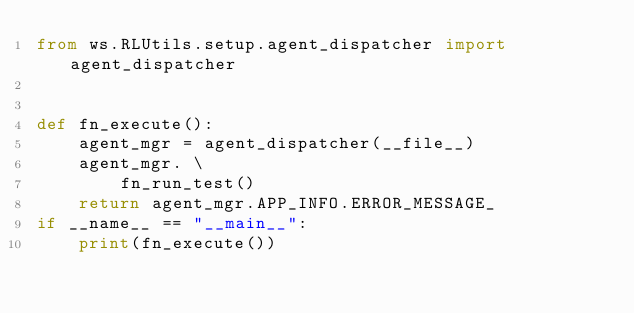Convert code to text. <code><loc_0><loc_0><loc_500><loc_500><_Python_>from ws.RLUtils.setup.agent_dispatcher import agent_dispatcher


def fn_execute():
    agent_mgr = agent_dispatcher(__file__)
    agent_mgr. \
        fn_run_test()
    return agent_mgr.APP_INFO.ERROR_MESSAGE_
if __name__ == "__main__":
    print(fn_execute())
</code> 